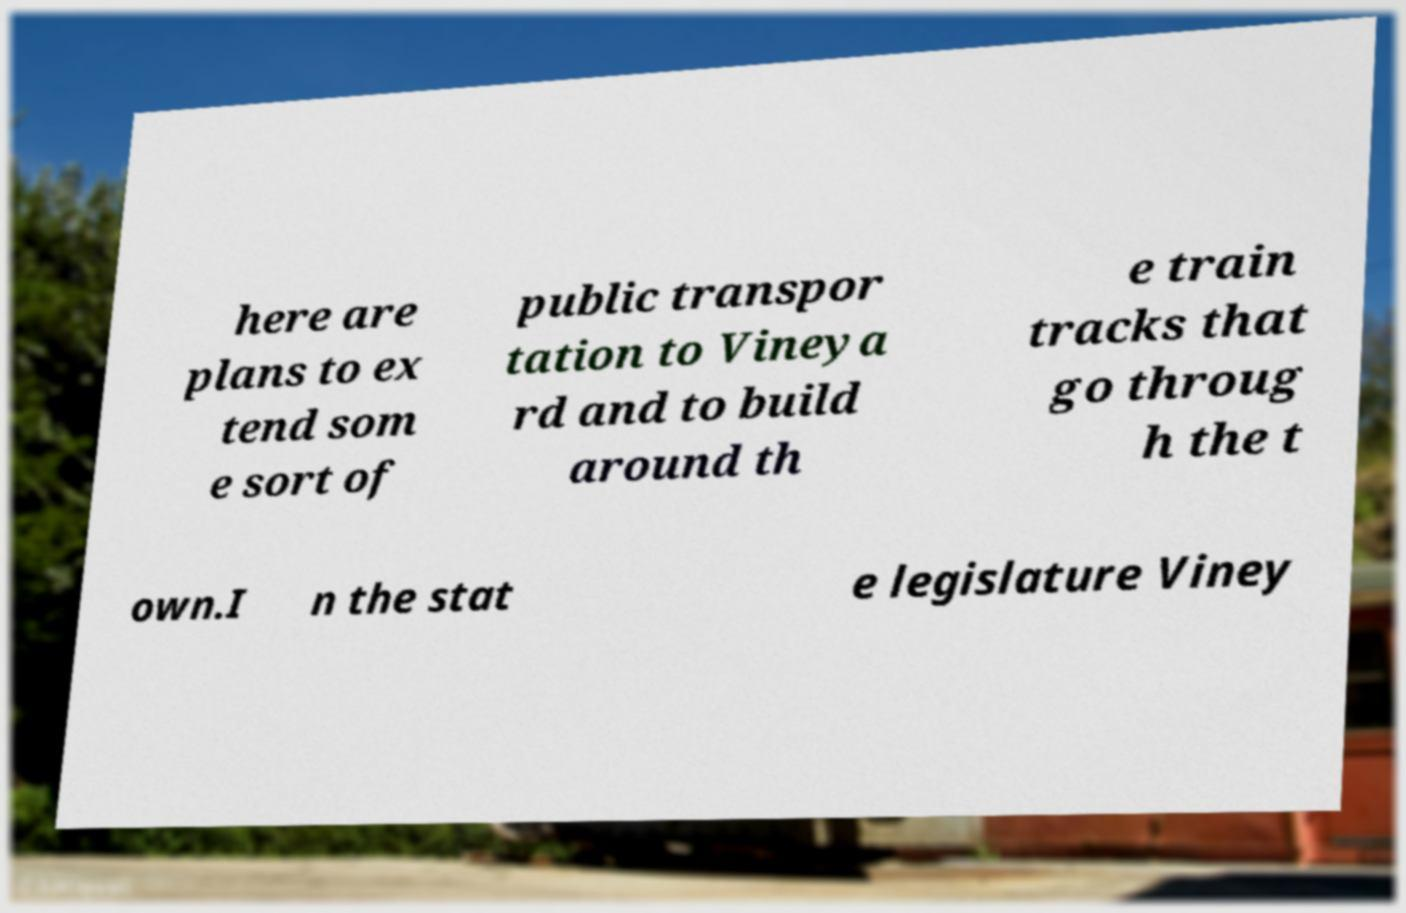What messages or text are displayed in this image? I need them in a readable, typed format. here are plans to ex tend som e sort of public transpor tation to Vineya rd and to build around th e train tracks that go throug h the t own.I n the stat e legislature Viney 